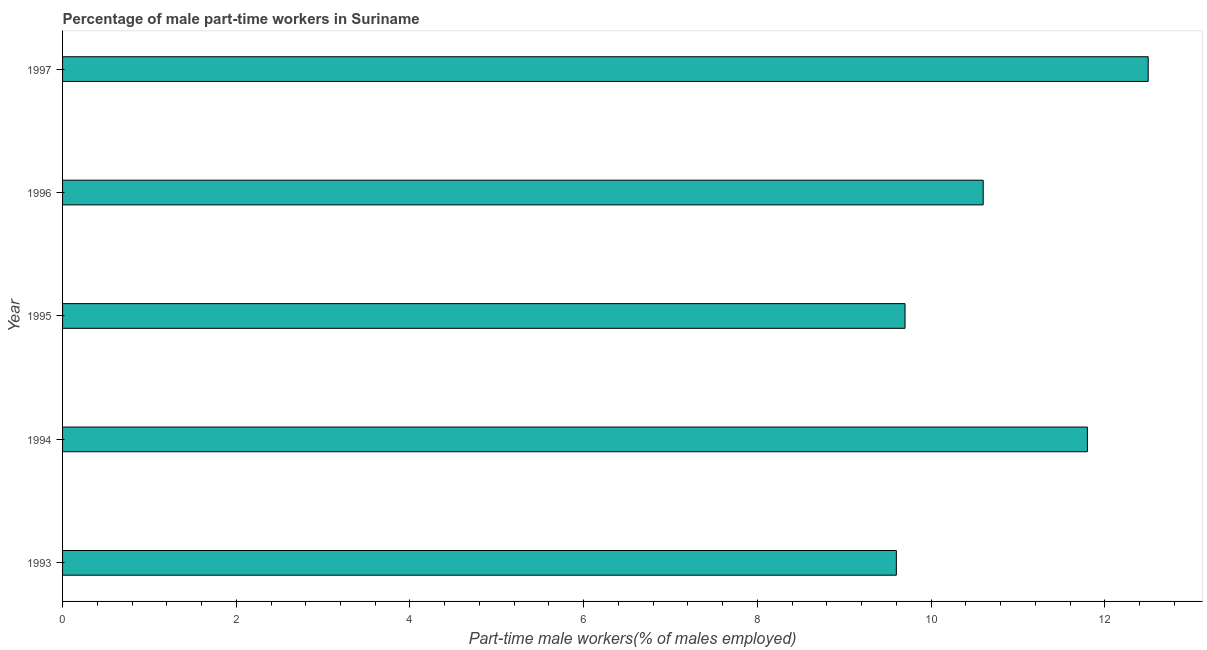What is the title of the graph?
Keep it short and to the point. Percentage of male part-time workers in Suriname. What is the label or title of the X-axis?
Offer a terse response. Part-time male workers(% of males employed). Across all years, what is the minimum percentage of part-time male workers?
Give a very brief answer. 9.6. In which year was the percentage of part-time male workers maximum?
Provide a short and direct response. 1997. In which year was the percentage of part-time male workers minimum?
Your response must be concise. 1993. What is the sum of the percentage of part-time male workers?
Offer a very short reply. 54.2. What is the difference between the percentage of part-time male workers in 1993 and 1996?
Offer a terse response. -1. What is the average percentage of part-time male workers per year?
Provide a succinct answer. 10.84. What is the median percentage of part-time male workers?
Make the answer very short. 10.6. In how many years, is the percentage of part-time male workers greater than 5.2 %?
Your answer should be very brief. 5. Do a majority of the years between 1993 and 1996 (inclusive) have percentage of part-time male workers greater than 11.6 %?
Keep it short and to the point. No. What is the ratio of the percentage of part-time male workers in 1994 to that in 1995?
Provide a succinct answer. 1.22. Is the difference between the percentage of part-time male workers in 1993 and 1997 greater than the difference between any two years?
Your response must be concise. Yes. What is the difference between the highest and the second highest percentage of part-time male workers?
Your response must be concise. 0.7. What is the difference between the highest and the lowest percentage of part-time male workers?
Your response must be concise. 2.9. How many bars are there?
Provide a succinct answer. 5. Are all the bars in the graph horizontal?
Ensure brevity in your answer.  Yes. How many years are there in the graph?
Your answer should be compact. 5. What is the difference between two consecutive major ticks on the X-axis?
Your response must be concise. 2. Are the values on the major ticks of X-axis written in scientific E-notation?
Give a very brief answer. No. What is the Part-time male workers(% of males employed) of 1993?
Provide a short and direct response. 9.6. What is the Part-time male workers(% of males employed) of 1994?
Your response must be concise. 11.8. What is the Part-time male workers(% of males employed) in 1995?
Provide a succinct answer. 9.7. What is the Part-time male workers(% of males employed) in 1996?
Give a very brief answer. 10.6. What is the difference between the Part-time male workers(% of males employed) in 1993 and 1994?
Ensure brevity in your answer.  -2.2. What is the difference between the Part-time male workers(% of males employed) in 1993 and 1995?
Provide a succinct answer. -0.1. What is the difference between the Part-time male workers(% of males employed) in 1993 and 1996?
Make the answer very short. -1. What is the difference between the Part-time male workers(% of males employed) in 1994 and 1995?
Offer a terse response. 2.1. What is the difference between the Part-time male workers(% of males employed) in 1994 and 1996?
Keep it short and to the point. 1.2. What is the difference between the Part-time male workers(% of males employed) in 1995 and 1996?
Offer a terse response. -0.9. What is the ratio of the Part-time male workers(% of males employed) in 1993 to that in 1994?
Your answer should be compact. 0.81. What is the ratio of the Part-time male workers(% of males employed) in 1993 to that in 1995?
Offer a terse response. 0.99. What is the ratio of the Part-time male workers(% of males employed) in 1993 to that in 1996?
Your response must be concise. 0.91. What is the ratio of the Part-time male workers(% of males employed) in 1993 to that in 1997?
Your answer should be compact. 0.77. What is the ratio of the Part-time male workers(% of males employed) in 1994 to that in 1995?
Make the answer very short. 1.22. What is the ratio of the Part-time male workers(% of males employed) in 1994 to that in 1996?
Provide a short and direct response. 1.11. What is the ratio of the Part-time male workers(% of males employed) in 1994 to that in 1997?
Ensure brevity in your answer.  0.94. What is the ratio of the Part-time male workers(% of males employed) in 1995 to that in 1996?
Provide a succinct answer. 0.92. What is the ratio of the Part-time male workers(% of males employed) in 1995 to that in 1997?
Ensure brevity in your answer.  0.78. What is the ratio of the Part-time male workers(% of males employed) in 1996 to that in 1997?
Offer a terse response. 0.85. 